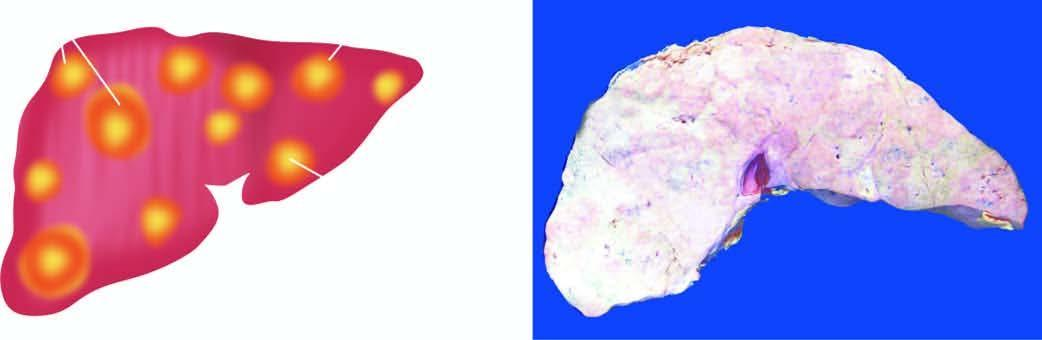s metastatic tumour deposits in the liver as seen on sectioned surface?
Answer the question using a single word or phrase. Yes 